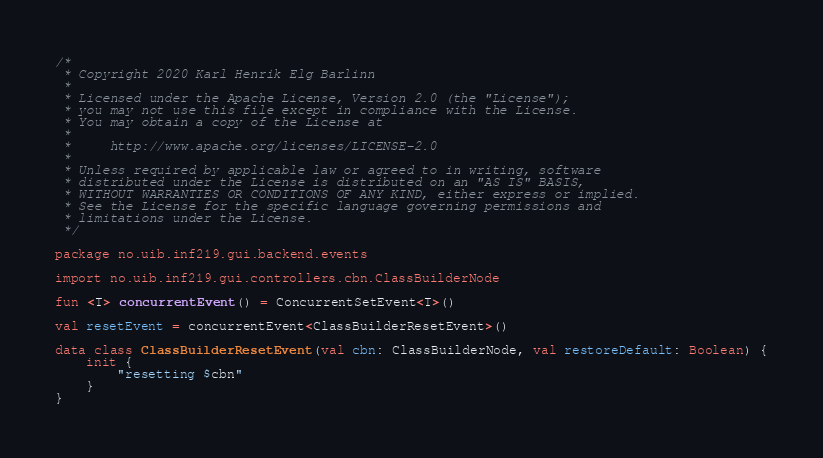<code> <loc_0><loc_0><loc_500><loc_500><_Kotlin_>/*
 * Copyright 2020 Karl Henrik Elg Barlinn
 *
 * Licensed under the Apache License, Version 2.0 (the "License");
 * you may not use this file except in compliance with the License.
 * You may obtain a copy of the License at
 *
 *     http://www.apache.org/licenses/LICENSE-2.0
 *
 * Unless required by applicable law or agreed to in writing, software
 * distributed under the License is distributed on an "AS IS" BASIS,
 * WITHOUT WARRANTIES OR CONDITIONS OF ANY KIND, either express or implied.
 * See the License for the specific language governing permissions and
 * limitations under the License.
 */

package no.uib.inf219.gui.backend.events

import no.uib.inf219.gui.controllers.cbn.ClassBuilderNode

fun <T> concurrentEvent() = ConcurrentSetEvent<T>()

val resetEvent = concurrentEvent<ClassBuilderResetEvent>()

data class ClassBuilderResetEvent(val cbn: ClassBuilderNode, val restoreDefault: Boolean) {
    init {
        "resetting $cbn"
    }
}
</code> 